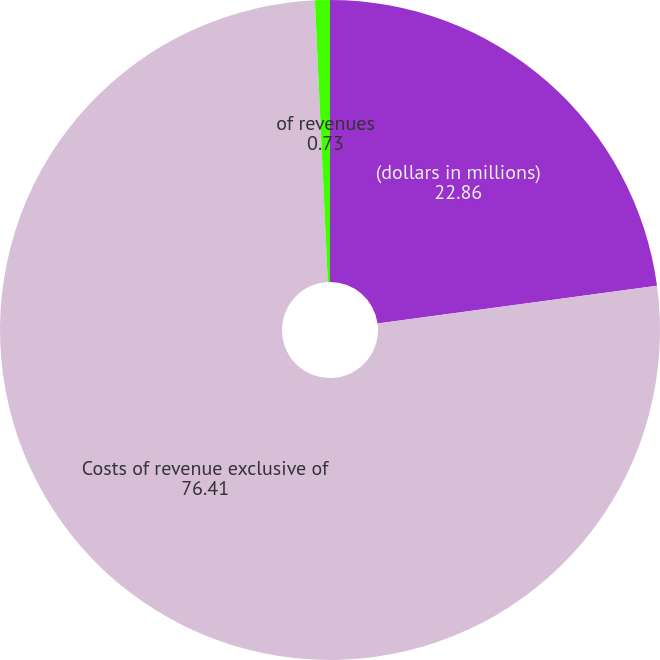Convert chart to OTSL. <chart><loc_0><loc_0><loc_500><loc_500><pie_chart><fcel>(dollars in millions)<fcel>Costs of revenue exclusive of<fcel>of revenues<nl><fcel>22.86%<fcel>76.41%<fcel>0.73%<nl></chart> 